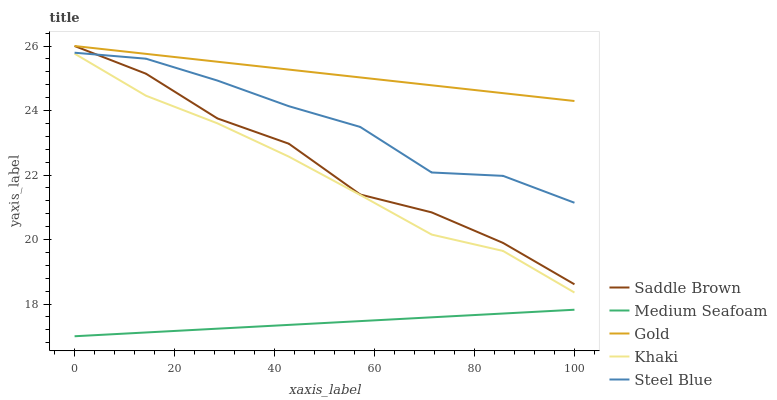Does Medium Seafoam have the minimum area under the curve?
Answer yes or no. Yes. Does Gold have the maximum area under the curve?
Answer yes or no. Yes. Does Khaki have the minimum area under the curve?
Answer yes or no. No. Does Khaki have the maximum area under the curve?
Answer yes or no. No. Is Medium Seafoam the smoothest?
Answer yes or no. Yes. Is Saddle Brown the roughest?
Answer yes or no. Yes. Is Khaki the smoothest?
Answer yes or no. No. Is Khaki the roughest?
Answer yes or no. No. Does Khaki have the lowest value?
Answer yes or no. No. Does Gold have the highest value?
Answer yes or no. Yes. Does Khaki have the highest value?
Answer yes or no. No. Is Khaki less than Steel Blue?
Answer yes or no. Yes. Is Steel Blue greater than Khaki?
Answer yes or no. Yes. Does Khaki intersect Steel Blue?
Answer yes or no. No. 